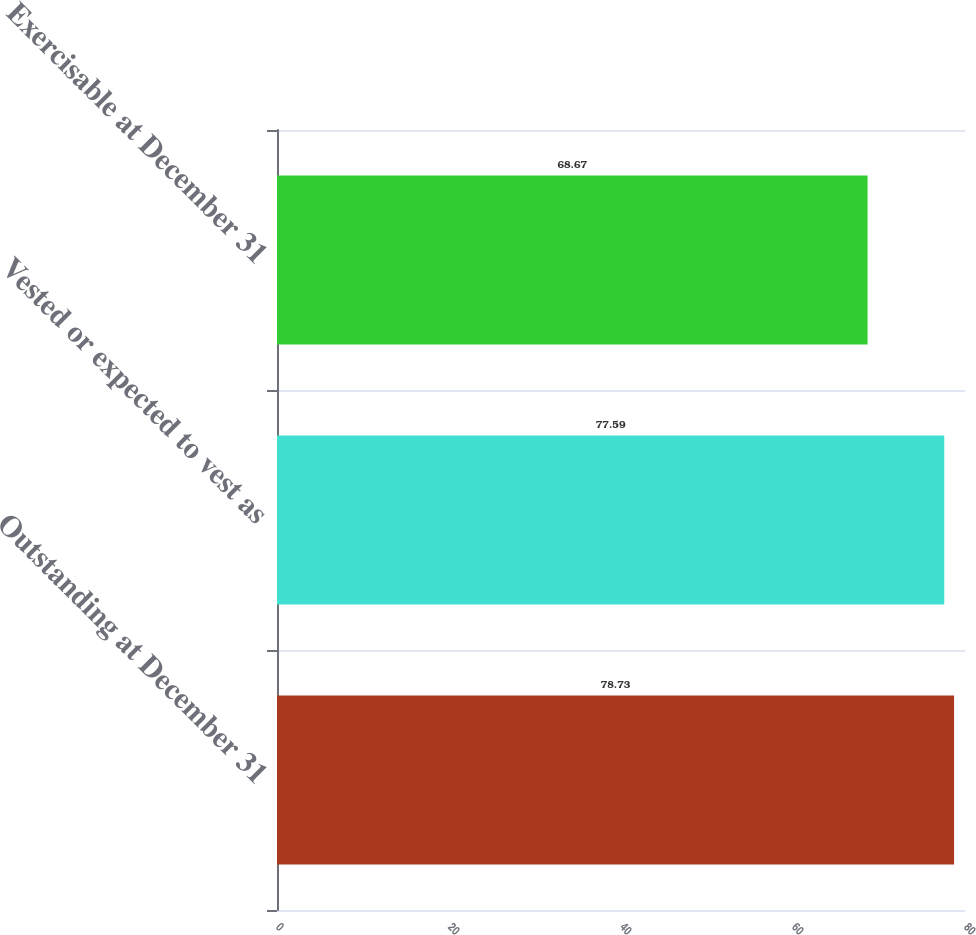Convert chart. <chart><loc_0><loc_0><loc_500><loc_500><bar_chart><fcel>Outstanding at December 31<fcel>Vested or expected to vest as<fcel>Exercisable at December 31<nl><fcel>78.73<fcel>77.59<fcel>68.67<nl></chart> 